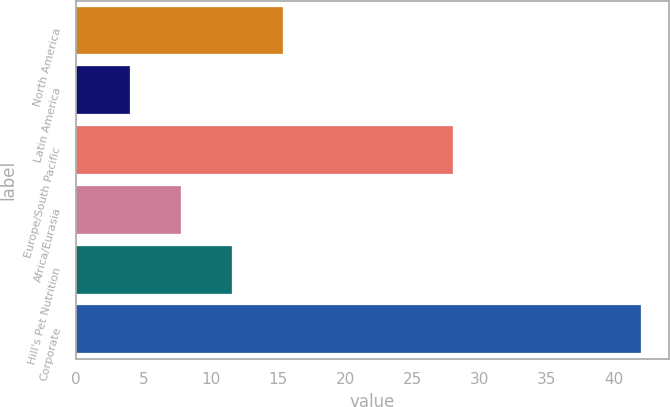Convert chart to OTSL. <chart><loc_0><loc_0><loc_500><loc_500><bar_chart><fcel>North America<fcel>Latin America<fcel>Europe/South Pacific<fcel>Africa/Eurasia<fcel>Hill's Pet Nutrition<fcel>Corporate<nl><fcel>15.4<fcel>4<fcel>28<fcel>7.8<fcel>11.6<fcel>42<nl></chart> 